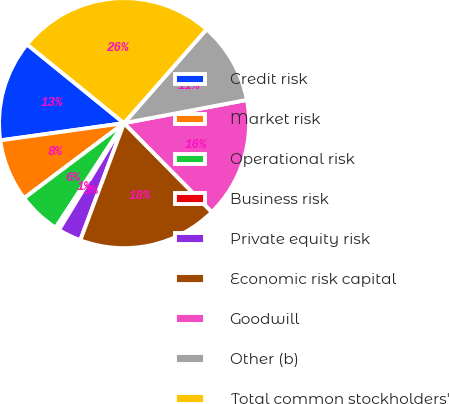Convert chart. <chart><loc_0><loc_0><loc_500><loc_500><pie_chart><fcel>Credit risk<fcel>Market risk<fcel>Operational risk<fcel>Business risk<fcel>Private equity risk<fcel>Economic risk capital<fcel>Goodwill<fcel>Other (b)<fcel>Total common stockholders'<nl><fcel>13.06%<fcel>8.04%<fcel>5.53%<fcel>0.51%<fcel>3.02%<fcel>18.09%<fcel>15.57%<fcel>10.55%<fcel>25.62%<nl></chart> 